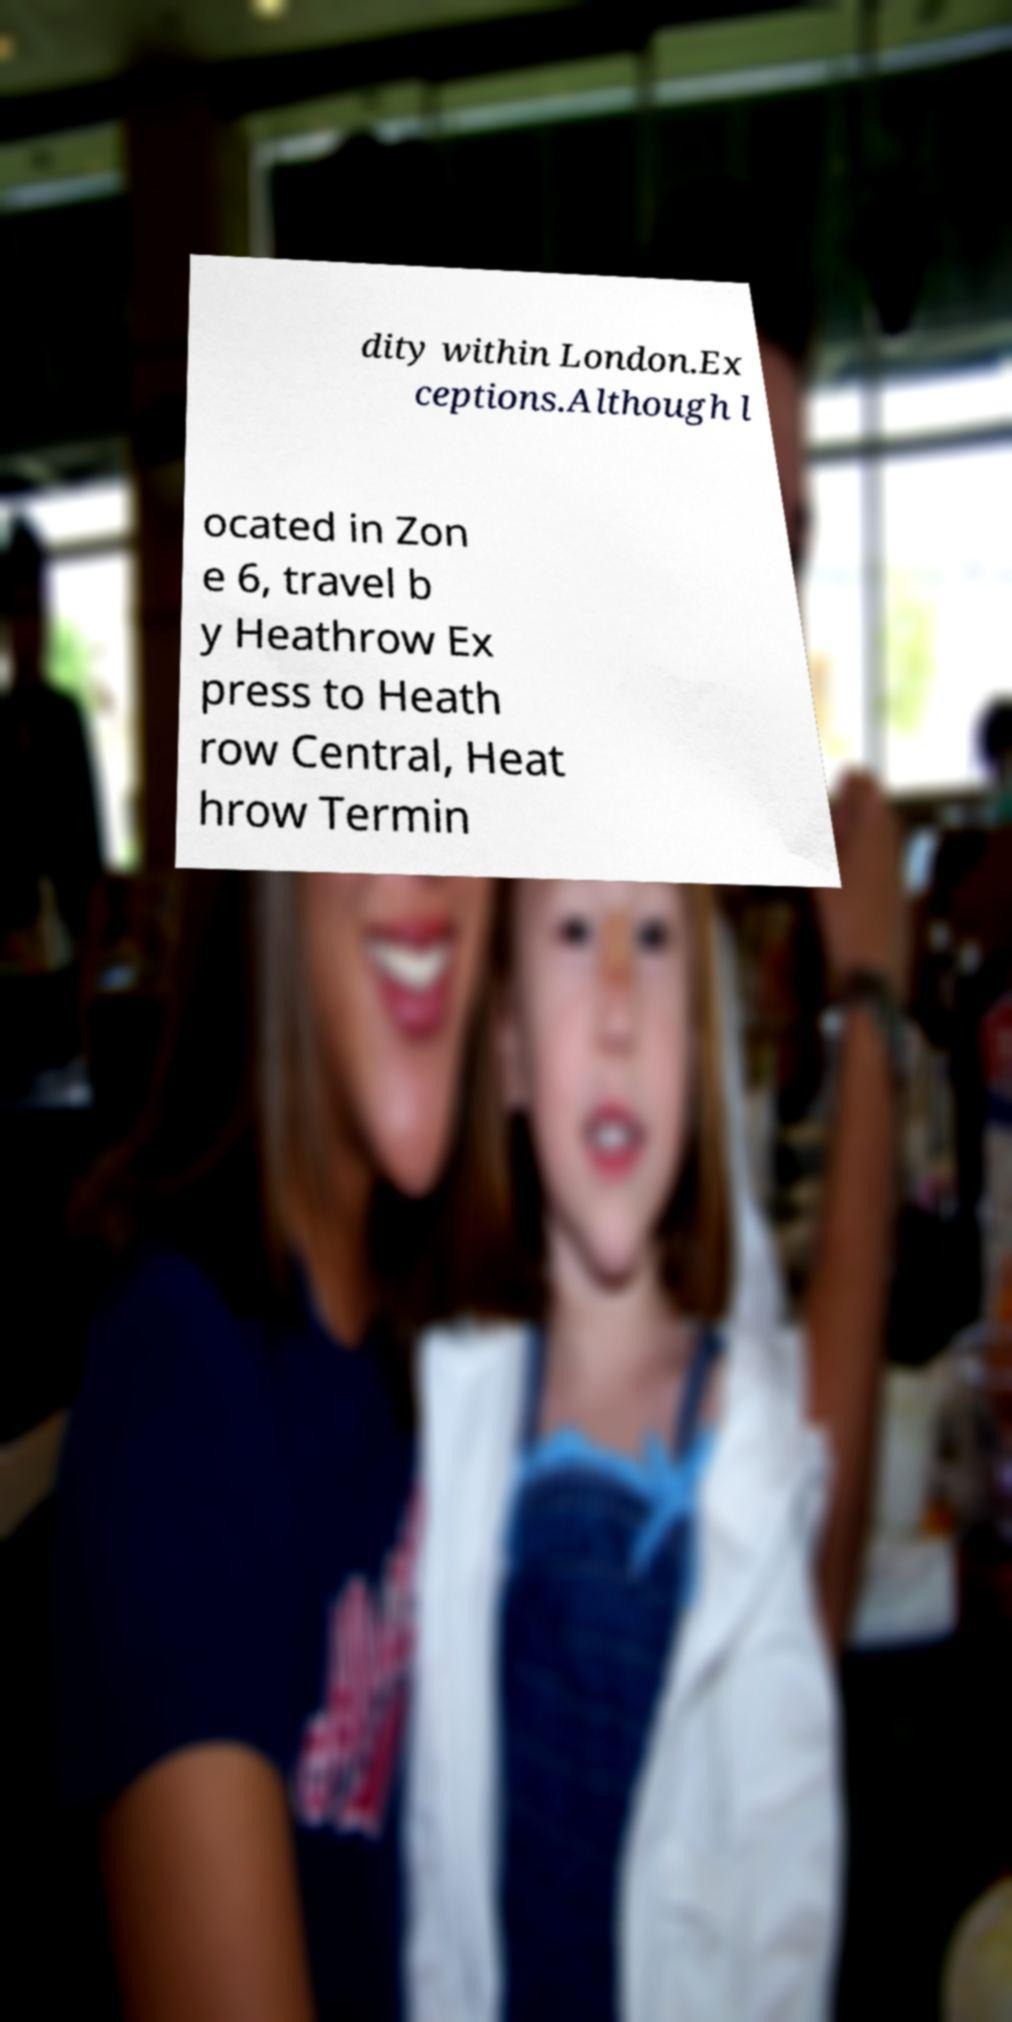There's text embedded in this image that I need extracted. Can you transcribe it verbatim? dity within London.Ex ceptions.Although l ocated in Zon e 6, travel b y Heathrow Ex press to Heath row Central, Heat hrow Termin 